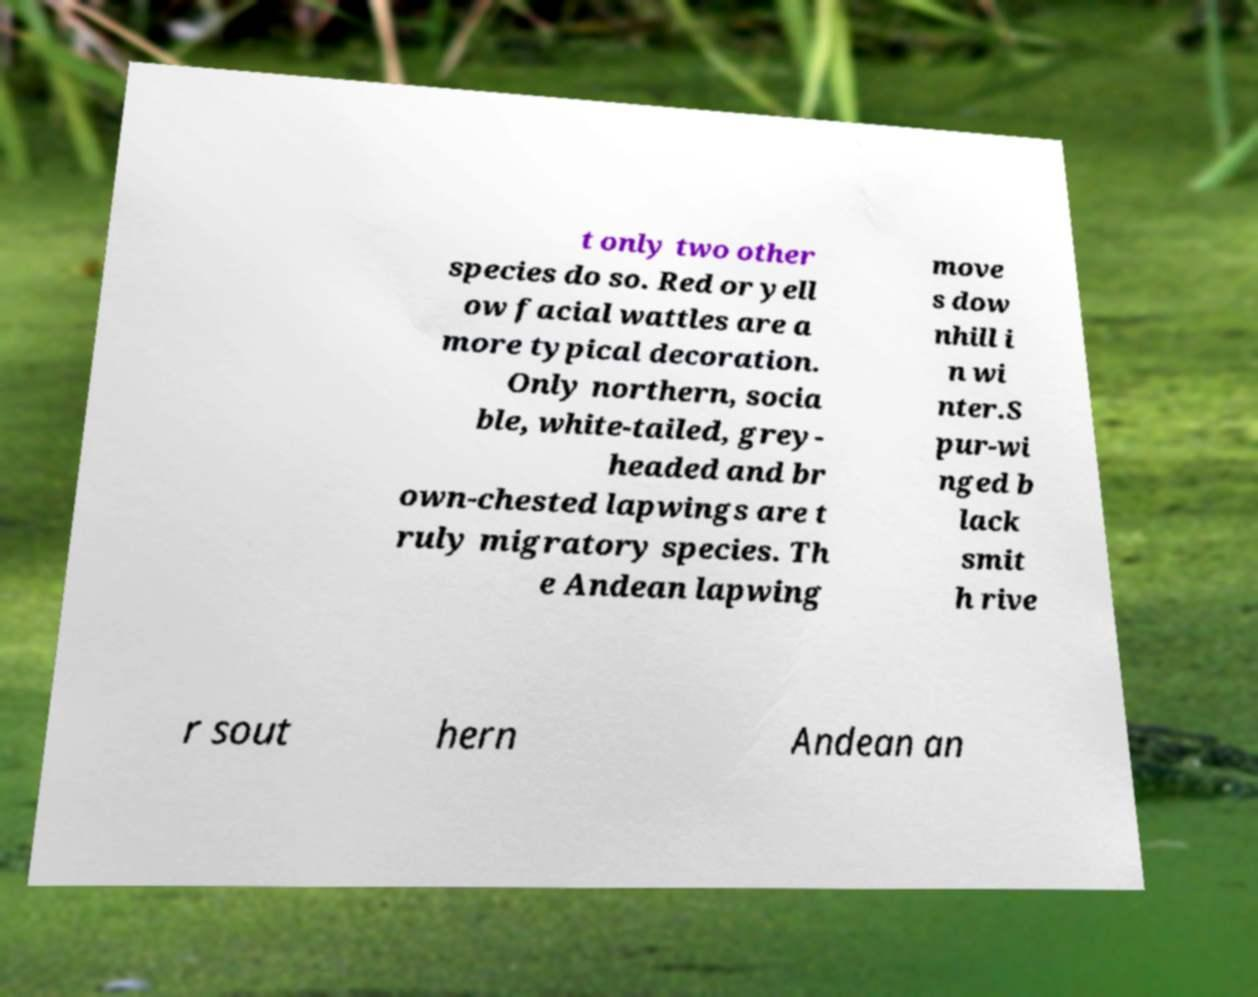Can you accurately transcribe the text from the provided image for me? t only two other species do so. Red or yell ow facial wattles are a more typical decoration. Only northern, socia ble, white-tailed, grey- headed and br own-chested lapwings are t ruly migratory species. Th e Andean lapwing move s dow nhill i n wi nter.S pur-wi nged b lack smit h rive r sout hern Andean an 